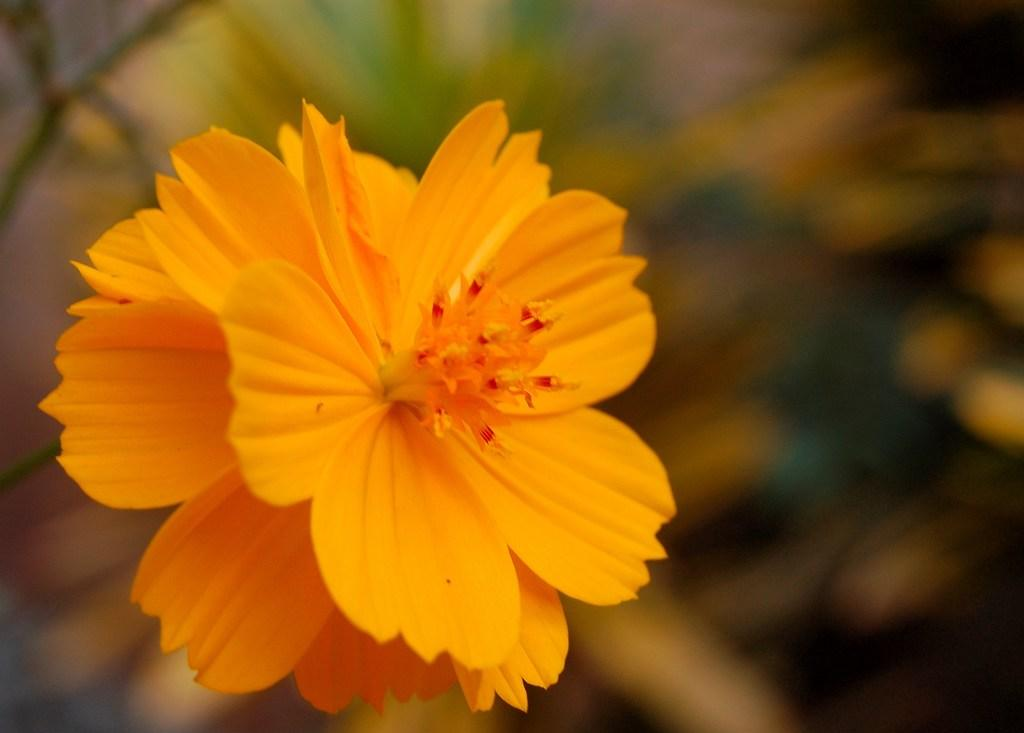What is the main subject of the image? There is a flower in the image. Can you describe the background of the image? The background of the image is blurry. What type of fruit is being advertised by the company in the image? There is no company or fruit present in the image; it features a flower with a blurry background. 